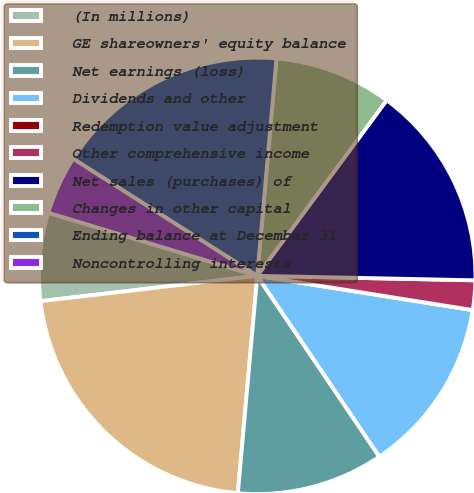Convert chart to OTSL. <chart><loc_0><loc_0><loc_500><loc_500><pie_chart><fcel>(In millions)<fcel>GE shareowners' equity balance<fcel>Net earnings (loss)<fcel>Dividends and other<fcel>Redemption value adjustment<fcel>Other comprehensive income<fcel>Net sales (purchases) of<fcel>Changes in other capital<fcel>Ending balance at December 31<fcel>Noncontrolling interests<nl><fcel>6.52%<fcel>21.73%<fcel>10.87%<fcel>13.04%<fcel>0.0%<fcel>2.18%<fcel>15.22%<fcel>8.7%<fcel>17.39%<fcel>4.35%<nl></chart> 